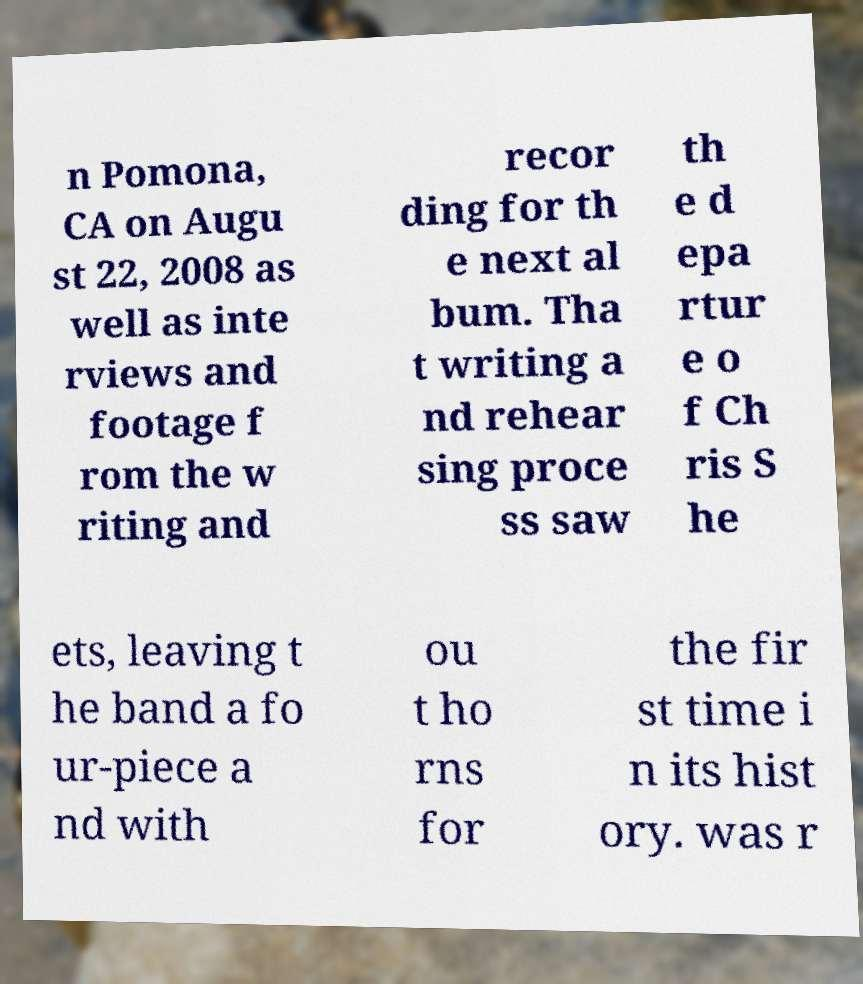What messages or text are displayed in this image? I need them in a readable, typed format. n Pomona, CA on Augu st 22, 2008 as well as inte rviews and footage f rom the w riting and recor ding for th e next al bum. Tha t writing a nd rehear sing proce ss saw th e d epa rtur e o f Ch ris S he ets, leaving t he band a fo ur-piece a nd with ou t ho rns for the fir st time i n its hist ory. was r 